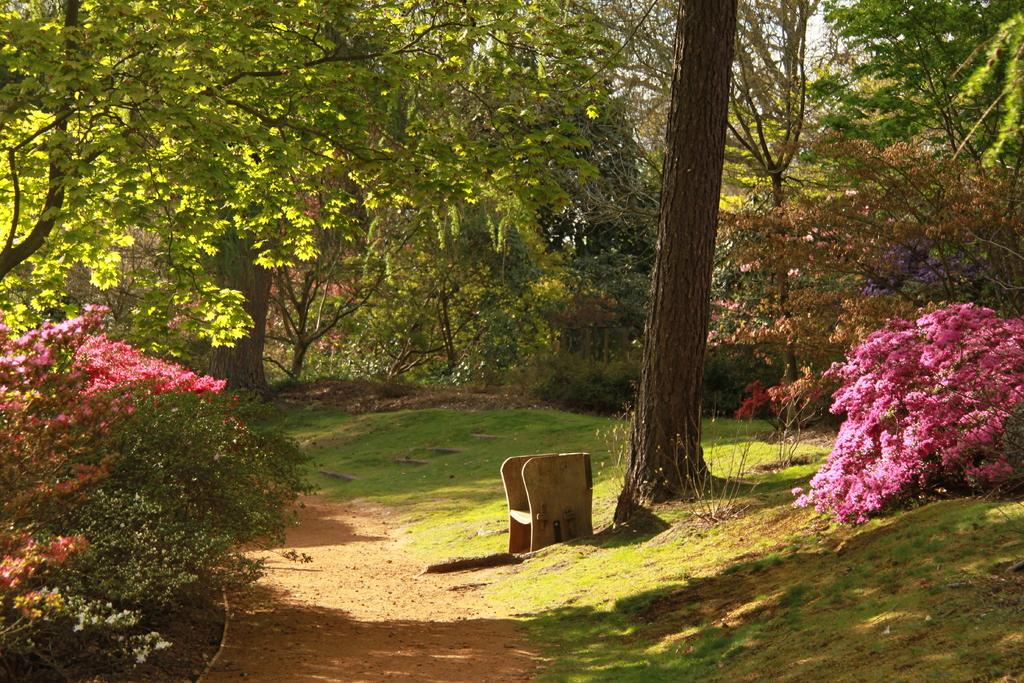What type of vegetation can be seen in the image? There are trees, plants, and flowers visible in the image. Where is the bench located in the image? The bench is at the bottom of the image. What is visible in the background of the image? The sky is visible in the background of the image. Who is the creator of the money visible in the image? There is no money visible in the image. How many arms are visible on the person sitting on the bench in the image? There is no person sitting on the bench in the image. 